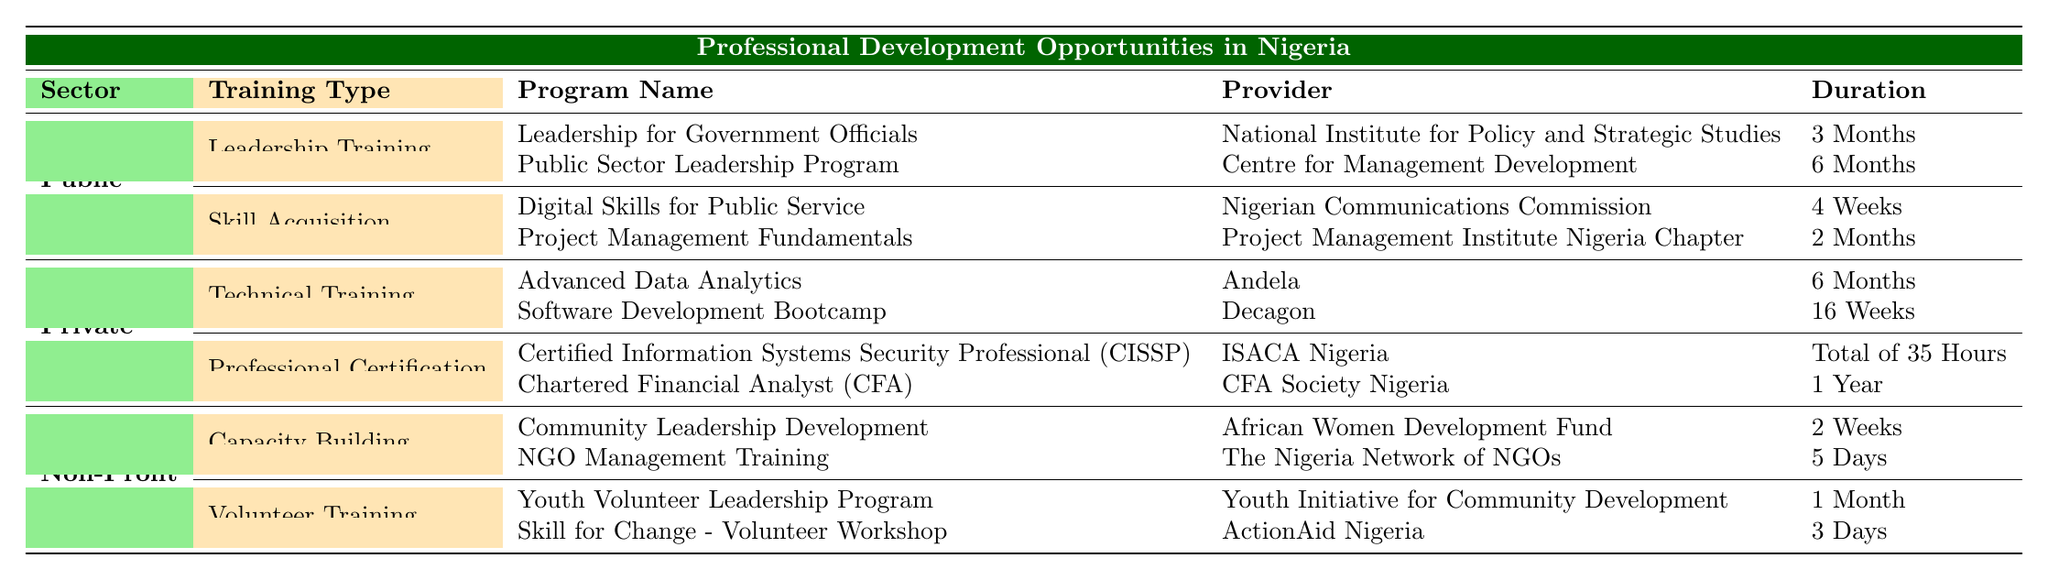What programs are offered for Leadership Training in the Public Sector? The table lists two programs under Leadership Training in the Public Sector: "Leadership for Government Officials" provided by the National Institute for Policy and Strategic Studies for a duration of 3 months, and "Public Sector Leadership Program" provided by the Centre for Management Development for 6 months.
Answer: Leadership for Government Officials and Public Sector Leadership Program How long is the duration of the Charter Financial Analyst program? The duration of the Charter Financial Analyst (CFA) program is stated in the table as 1 year.
Answer: 1 Year Is the Advanced Data Analytics program a Technical Training offered in the Private Sector? Yes, under the Private Sector training types, the Advanced Data Analytics program is classified as a Technical Training.
Answer: Yes Which sector provides the longest duration program and what is its name? By examining the table, the longest duration program is the Chartered Financial Analyst (CFA) offered in the Private Sector, which lasts for 1 year.
Answer: Chartered Financial Analyst (CFA) How many programs are listed under Volunteer Training and what is the average duration of these programs? The table lists two programs under Volunteer Training: "Youth Volunteer Leadership Program" (1 month) and "Skill for Change - Volunteer Workshop" (3 days). To find the average duration, we need to convert the durations to the same unit. 1 month is approximately 30 days, and adding both gives us 30 + 3 = 33 days. Dividing by 2 (the number of programs) gives us an average of 16.5 days.
Answer: 16.5 days Are there any Skill Acquisition programs in the Non-Profit Sector? No, the Non-Profit Sector does not list any Skill Acquisition programs in the table.
Answer: No Which provider offers a program with the shortest duration in the table and what is the program's name? The program with the shortest duration is "Skill for Change - Volunteer Workshop" (3 days) offered by ActionAid Nigeria.
Answer: Skill for Change - Volunteer Workshop What training type in the Private Sector has the most programs listed? In the Private Sector, the Training Type with the most programs is Professional Certification, which includes two programs: CISSP and CFA.
Answer: Professional Certification How do the number of programs in the Public Sector compare to those in the Non-Profit Sector? The Public Sector has four programs (two under Leadership Training and two under Skill Acquisition), while the Non-Profit Sector has four programs (two under Capacity Building and two under Volunteer Training). This indicates that the number of programs in both sectors is equal.
Answer: They are equal 